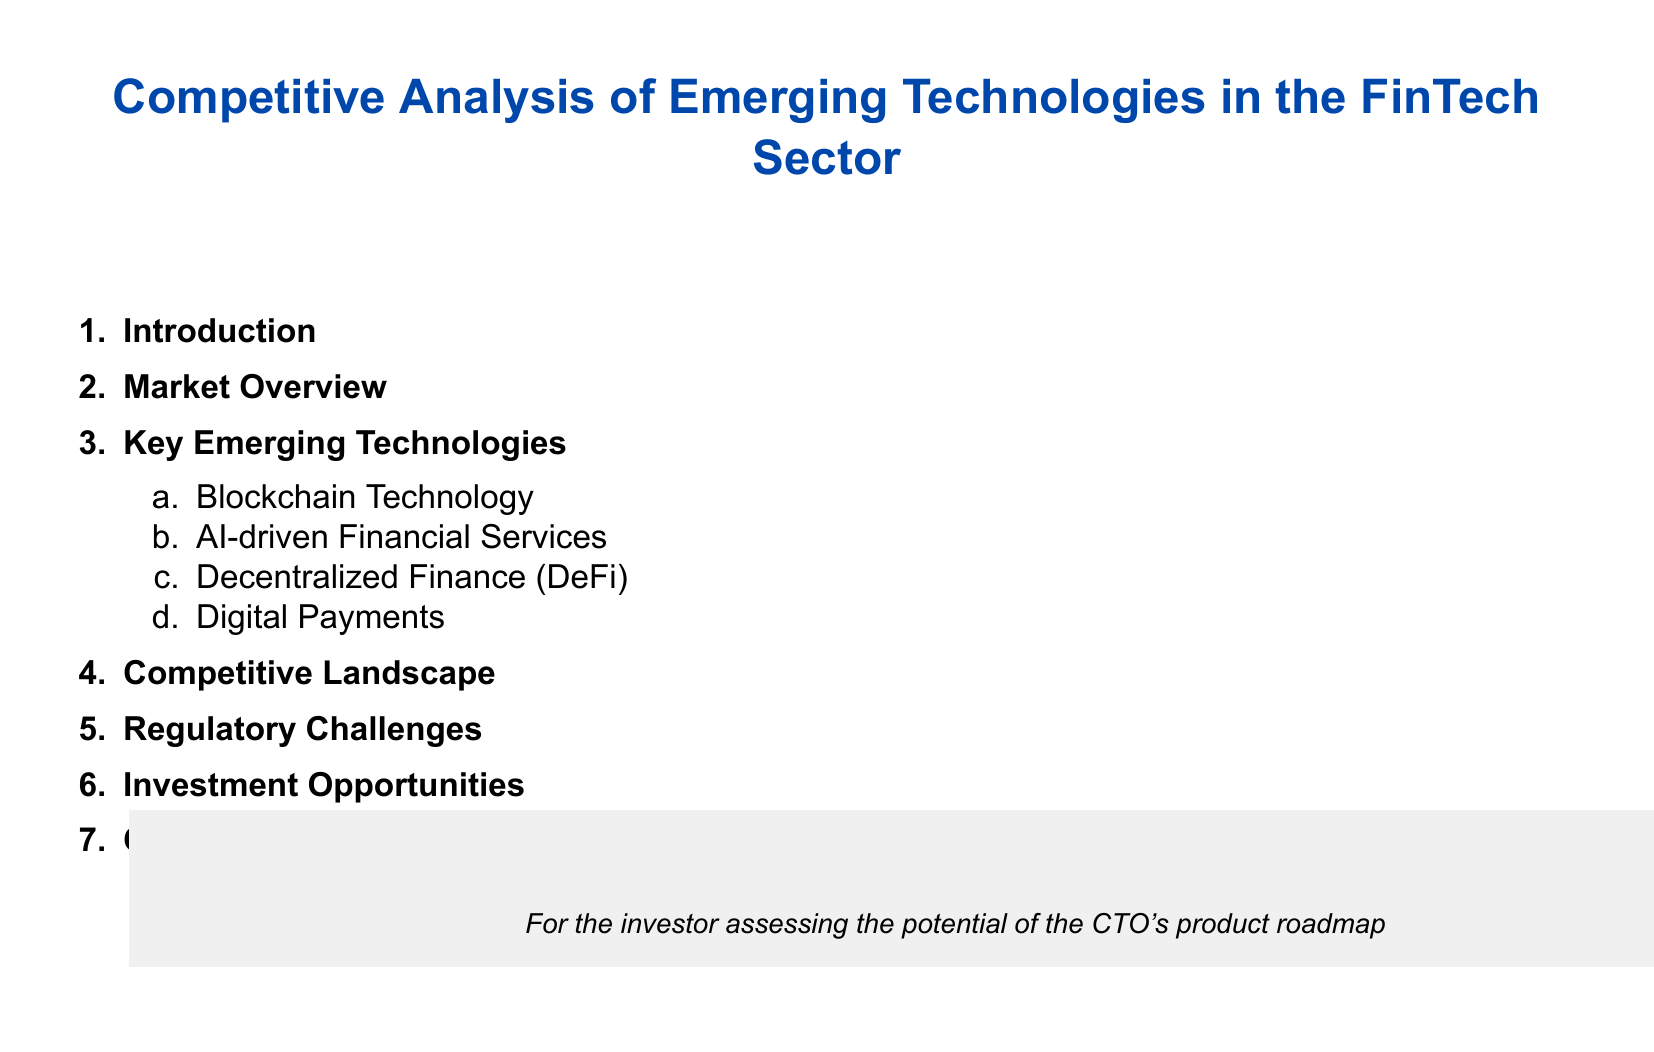What is the title of the document? The title is presented at the top of the document and indicates the subject matter it covers.
Answer: Competitive Analysis of Emerging Technologies in the FinTech Sector How many key emerging technologies are identified? The document lists several technologies, which can be counted in the provided section.
Answer: Four Which technology involves the use of distributed ledgers? Looking at the key emerging technologies, one specific technology utilizes this principle and is mentioned.
Answer: Blockchain Technology What is the main focus of the section after Key Emerging Technologies? This section follows logically from the discussion of technologies, aiming to provide further insights into the market context.
Answer: Competitive Landscape What type of challenges does the document address? The document highlights issues that can affect market players and influence technology adoption in FinTech.
Answer: Regulatory Challenges 